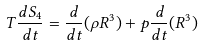<formula> <loc_0><loc_0><loc_500><loc_500>T \frac { d S _ { 4 } } { d t } = \frac { d } { d t } ( \rho R ^ { 3 } ) + p \frac { d } { d t } ( R ^ { 3 } )</formula> 